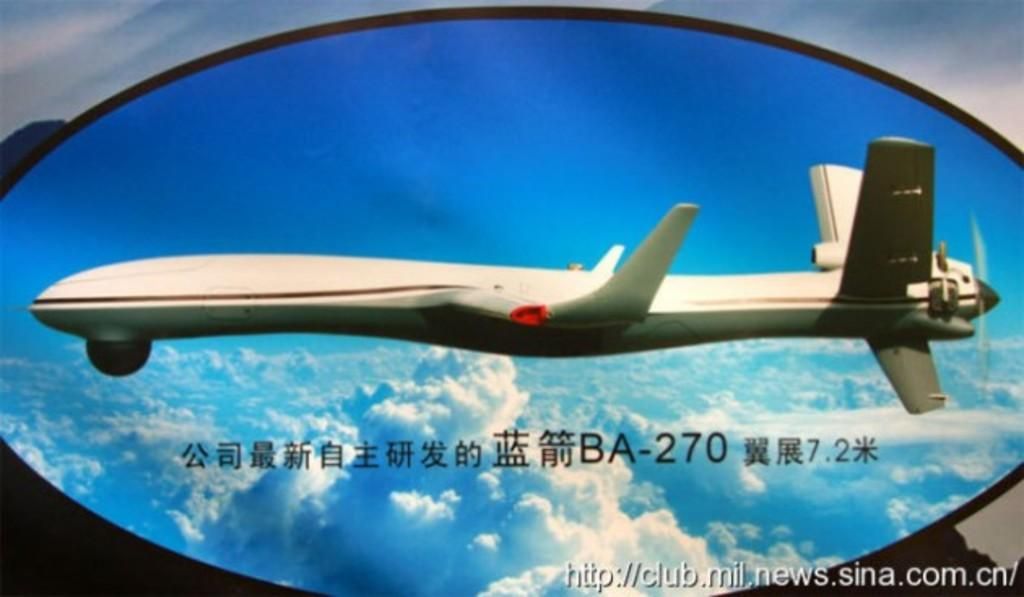What is happening in the sky in the image? There is an airplane flying in the sky. What else can be seen in the sky in the image? Clouds are visible in the sky. What is written in the image? There is something written in the image. Can you describe the watermark at the bottom of the image? There is a watermark at the bottom of the image. What type of music is the queen listening to in the image? There is no queen or music present in the image; it features an airplane flying in the sky with clouds and written content. Can you tell me the name of the governor mentioned in the image? There is no governor mentioned in the image; it only contains a watermark at the bottom. 